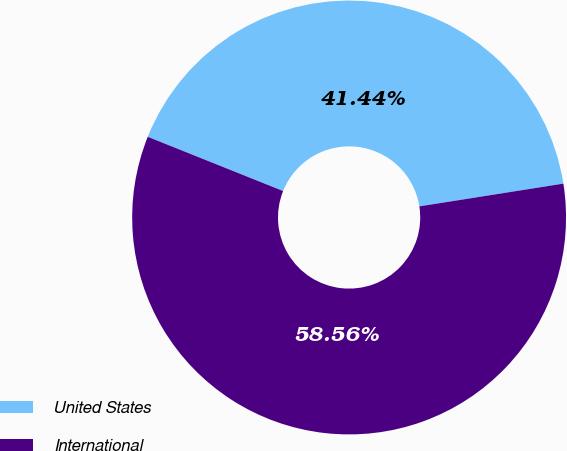<chart> <loc_0><loc_0><loc_500><loc_500><pie_chart><fcel>United States<fcel>International<nl><fcel>41.44%<fcel>58.56%<nl></chart> 